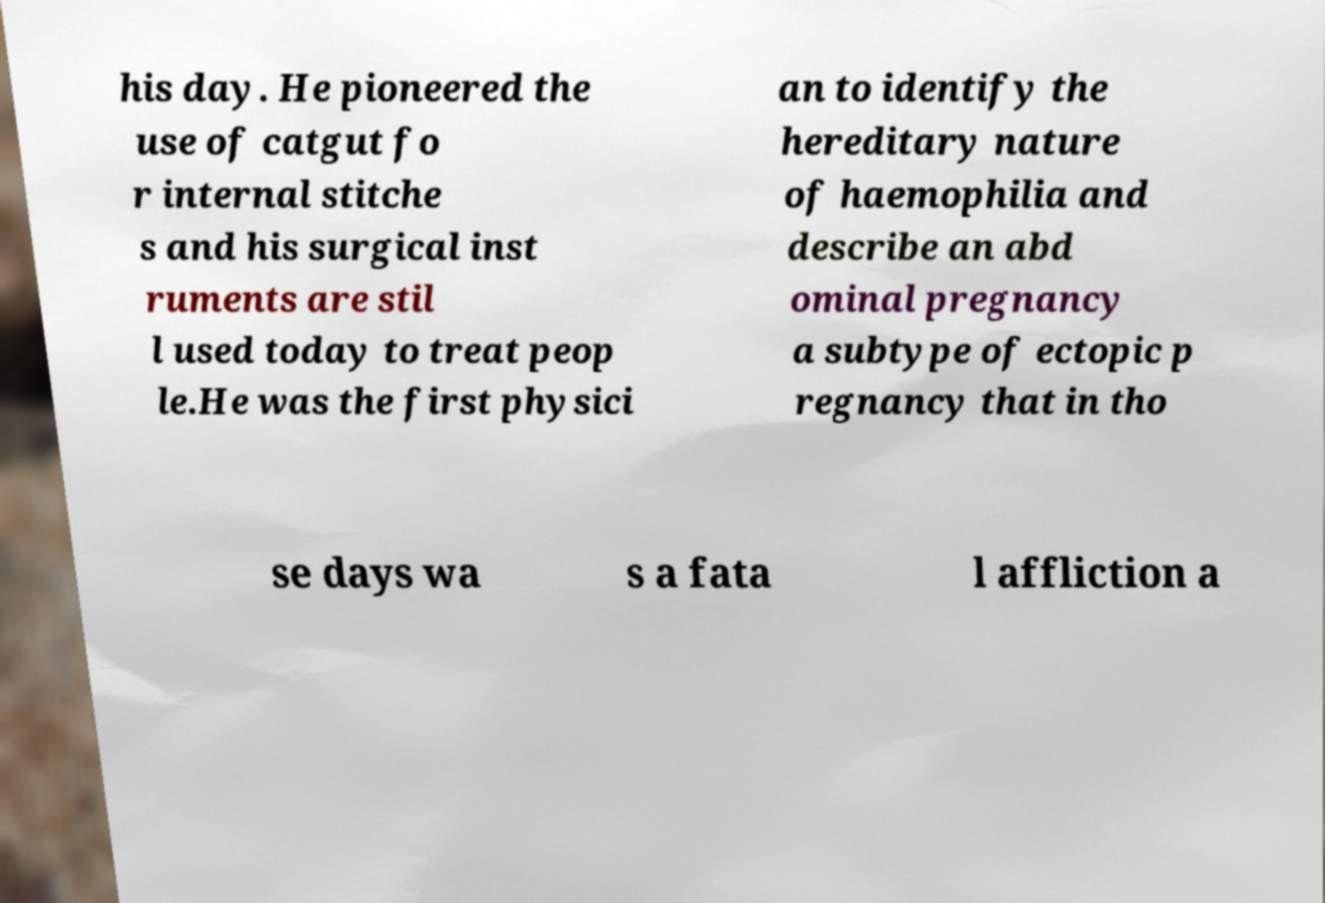I need the written content from this picture converted into text. Can you do that? his day. He pioneered the use of catgut fo r internal stitche s and his surgical inst ruments are stil l used today to treat peop le.He was the first physici an to identify the hereditary nature of haemophilia and describe an abd ominal pregnancy a subtype of ectopic p regnancy that in tho se days wa s a fata l affliction a 